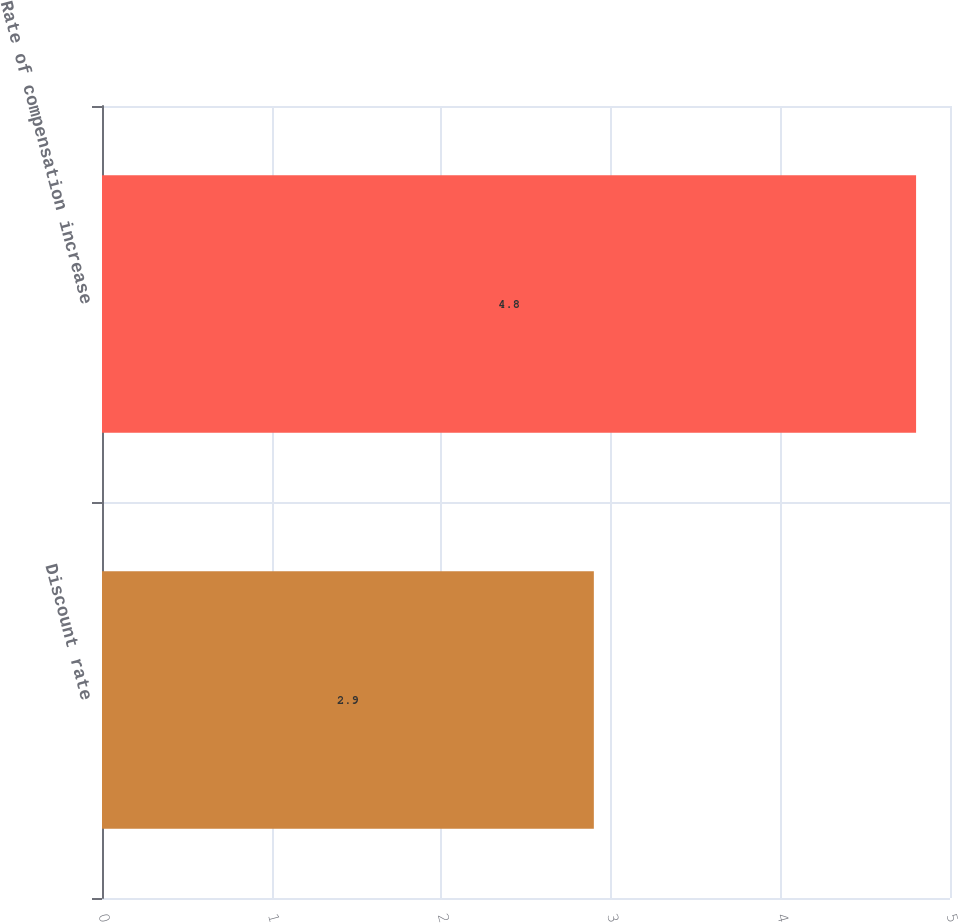Convert chart to OTSL. <chart><loc_0><loc_0><loc_500><loc_500><bar_chart><fcel>Discount rate<fcel>Rate of compensation increase<nl><fcel>2.9<fcel>4.8<nl></chart> 